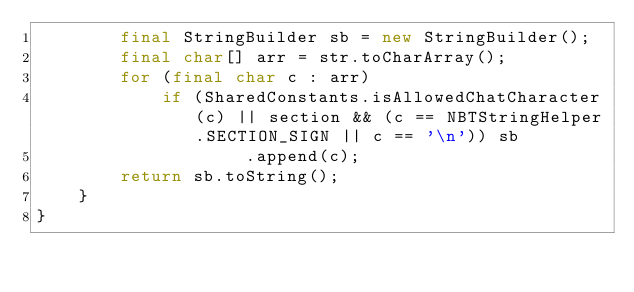Convert code to text. <code><loc_0><loc_0><loc_500><loc_500><_Java_>        final StringBuilder sb = new StringBuilder();
        final char[] arr = str.toCharArray();
        for (final char c : arr)
            if (SharedConstants.isAllowedChatCharacter(c) || section && (c == NBTStringHelper.SECTION_SIGN || c == '\n')) sb
                    .append(c);
        return sb.toString();
    }
}
</code> 